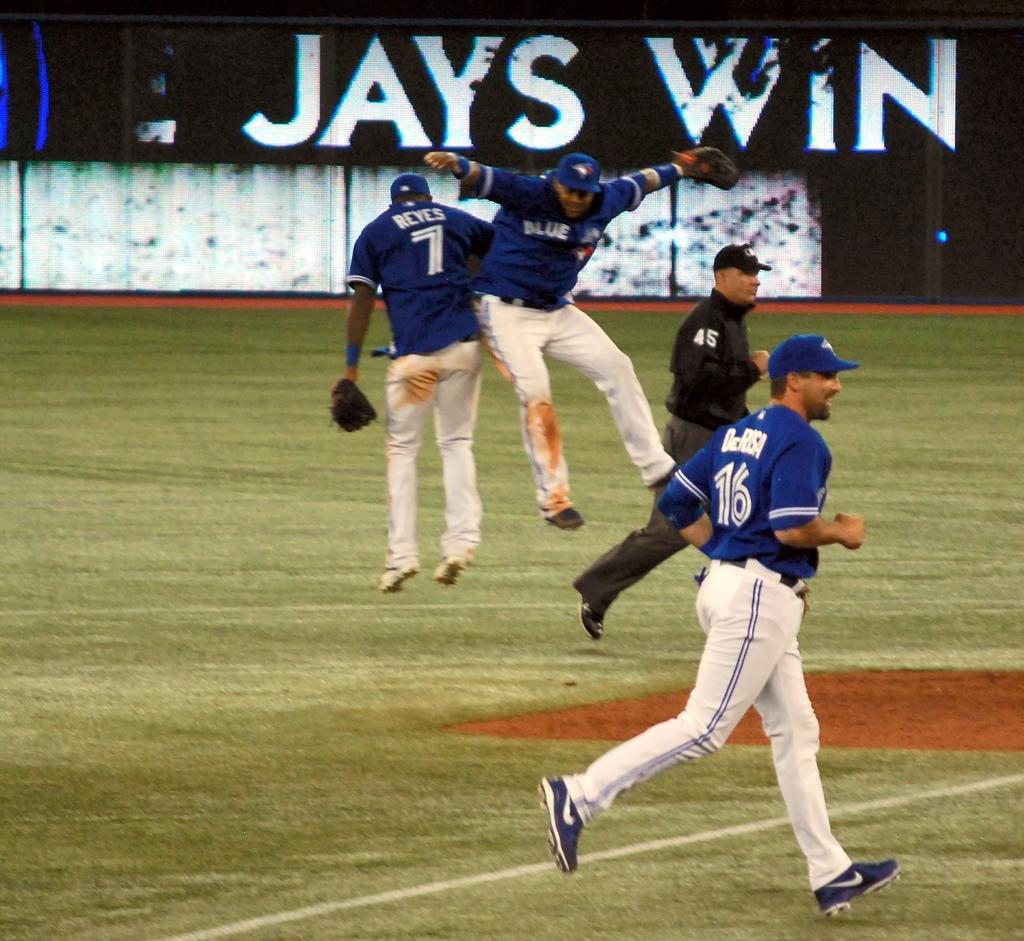What color of uniform is the referee wearing?
Offer a terse response. Answering does not require reading text in the image. What does the sign in the back say which team won?
Your response must be concise. Jays. 